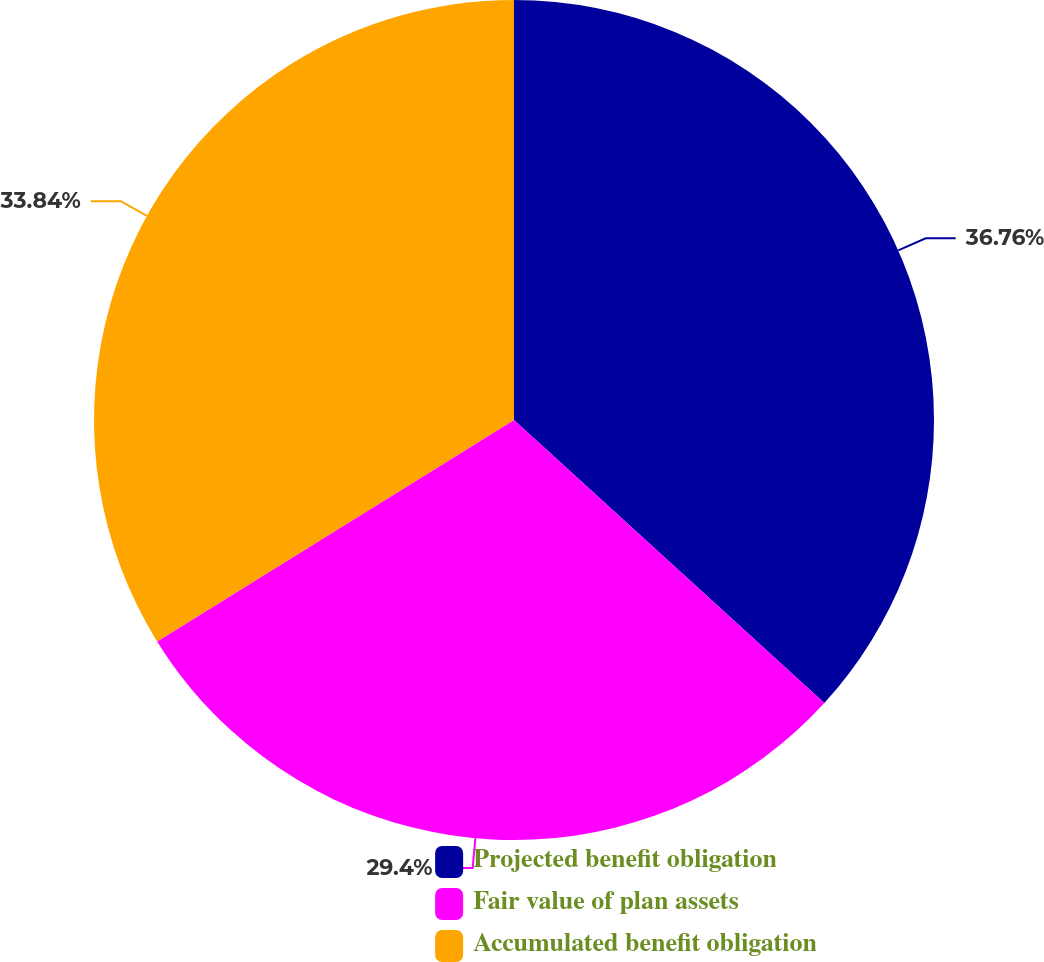Convert chart to OTSL. <chart><loc_0><loc_0><loc_500><loc_500><pie_chart><fcel>Projected benefit obligation<fcel>Fair value of plan assets<fcel>Accumulated benefit obligation<nl><fcel>36.77%<fcel>29.4%<fcel>33.84%<nl></chart> 